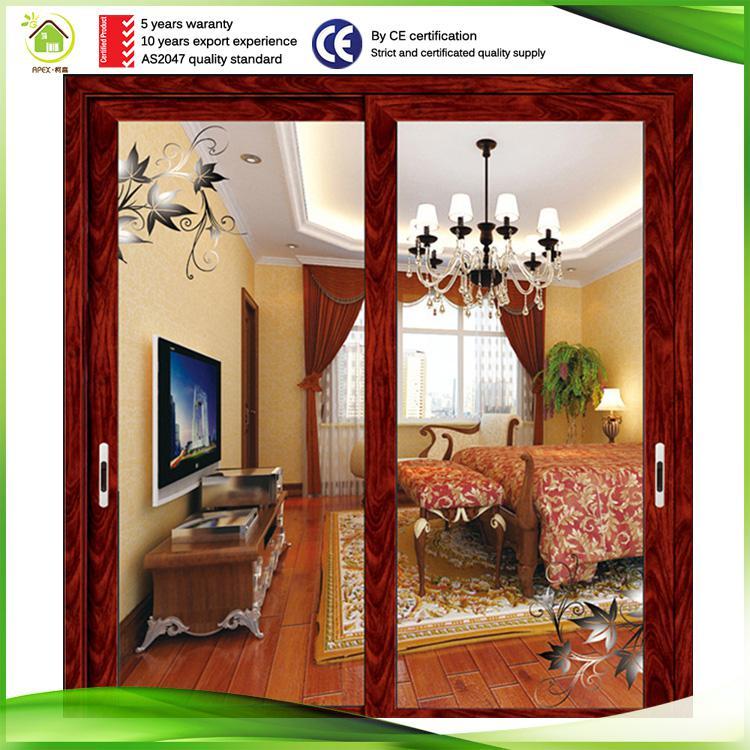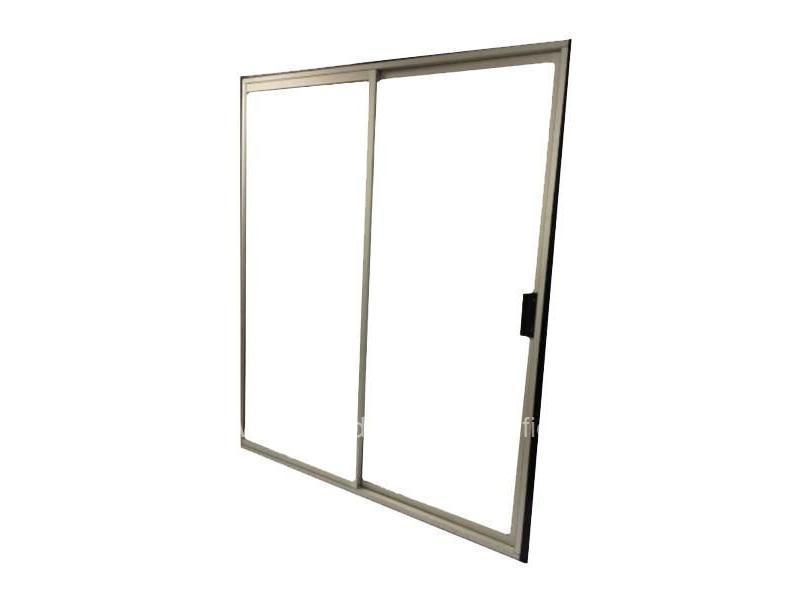The first image is the image on the left, the second image is the image on the right. Assess this claim about the two images: "One door is solid wood.". Correct or not? Answer yes or no. No. The first image is the image on the left, the second image is the image on the right. Assess this claim about the two images: "In at least one image there is a single hanging door on a track.". Correct or not? Answer yes or no. No. 